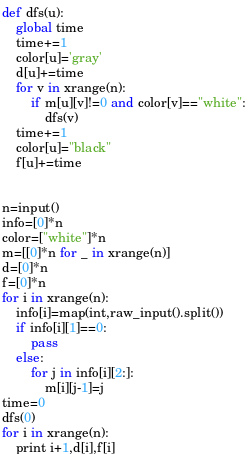Convert code to text. <code><loc_0><loc_0><loc_500><loc_500><_Python_>def dfs(u):
    global time
    time+=1
    color[u]='gray'
    d[u]+=time
    for v in xrange(n):
        if m[u][v]!=0 and color[v]=="white":
            dfs(v)
    time+=1
    color[u]="black"
    f[u]+=time
    

n=input()
info=[0]*n
color=["white"]*n
m=[[0]*n for _ in xrange(n)]
d=[0]*n
f=[0]*n
for i in xrange(n):
    info[i]=map(int,raw_input().split())
    if info[i][1]==0:
        pass
    else:
        for j in info[i][2:]:
            m[i][j-1]=j
time=0
dfs(0)
for i in xrange(n):
    print i+1,d[i],f[i]</code> 